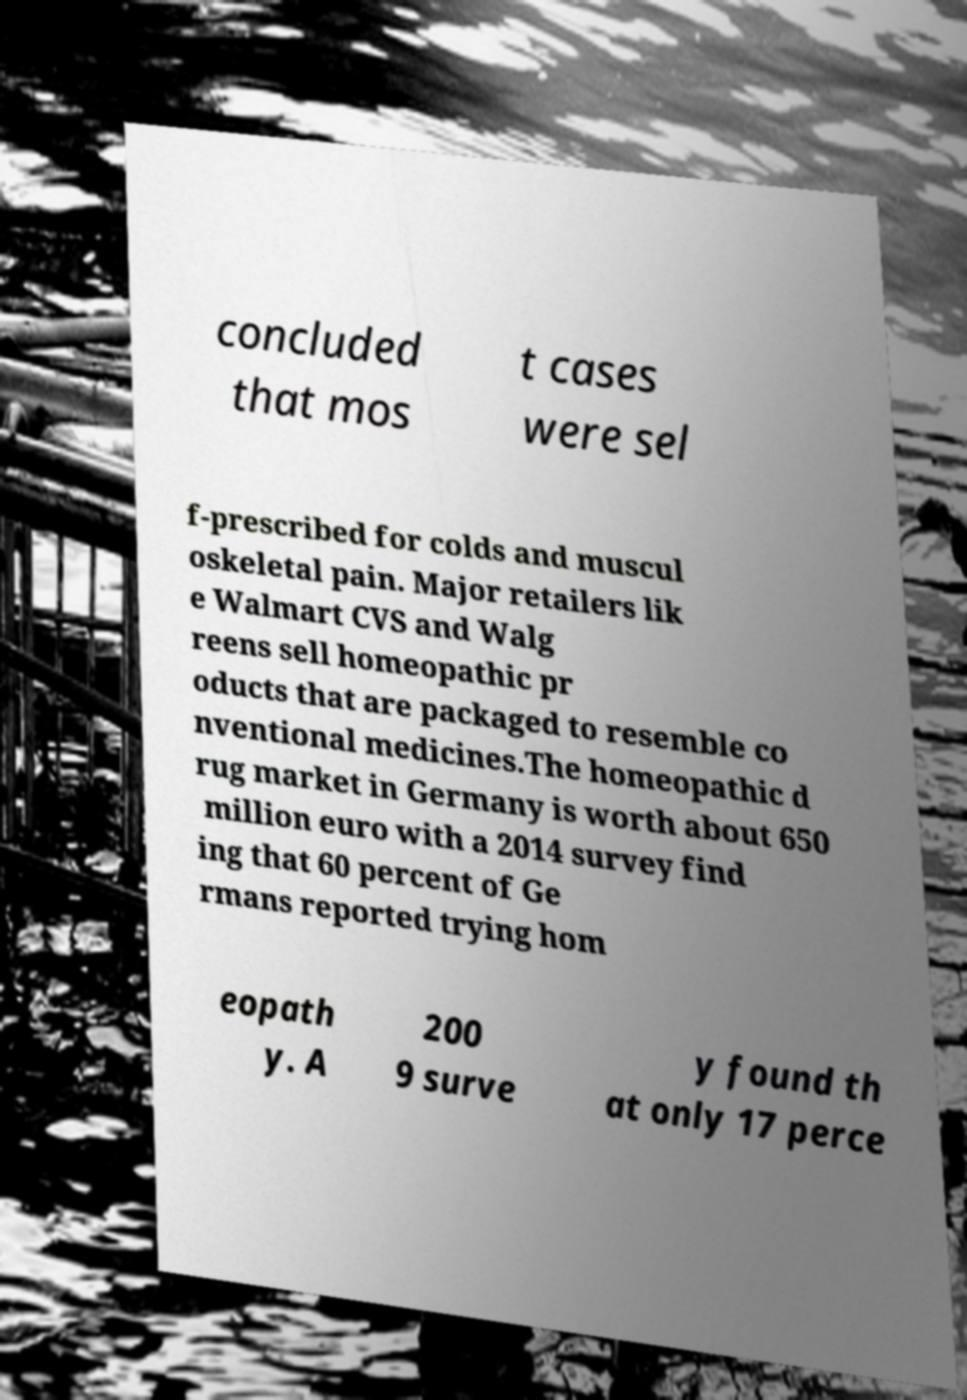Can you accurately transcribe the text from the provided image for me? concluded that mos t cases were sel f-prescribed for colds and muscul oskeletal pain. Major retailers lik e Walmart CVS and Walg reens sell homeopathic pr oducts that are packaged to resemble co nventional medicines.The homeopathic d rug market in Germany is worth about 650 million euro with a 2014 survey find ing that 60 percent of Ge rmans reported trying hom eopath y. A 200 9 surve y found th at only 17 perce 